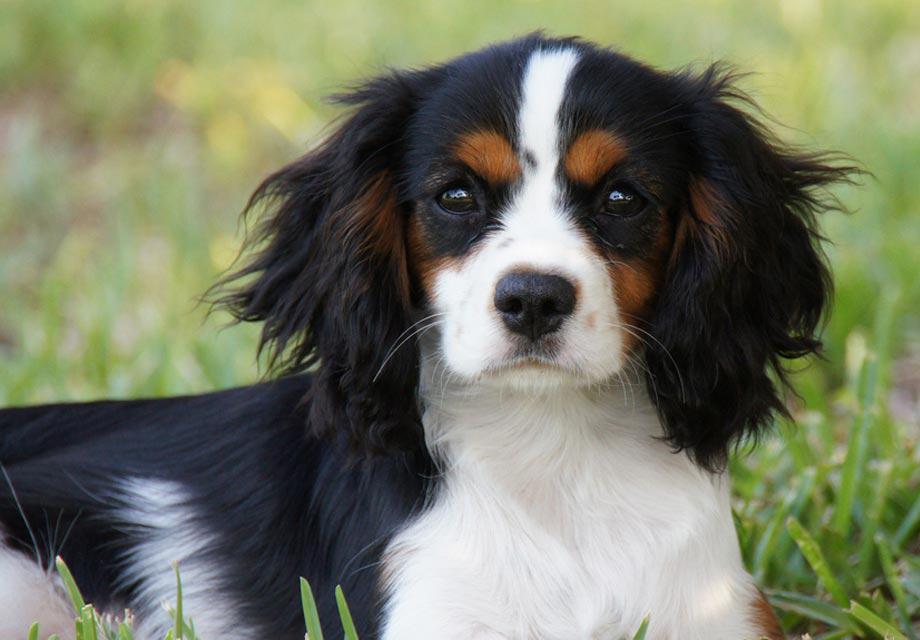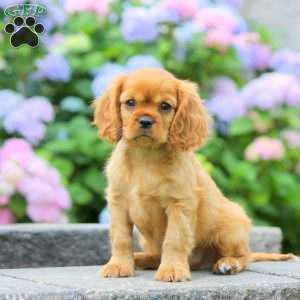The first image is the image on the left, the second image is the image on the right. Examine the images to the left and right. Is the description "There are at least two puppies in the right image." accurate? Answer yes or no. No. The first image is the image on the left, the second image is the image on the right. Considering the images on both sides, is "Left image contains a puppy wearing a pink heart charm on its collar." valid? Answer yes or no. No. 